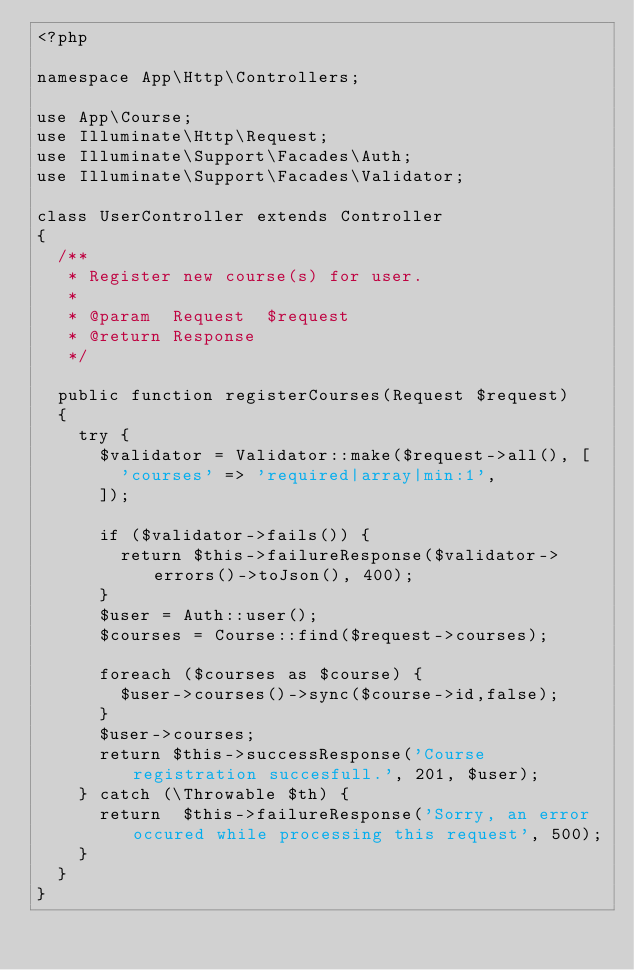Convert code to text. <code><loc_0><loc_0><loc_500><loc_500><_PHP_><?php

namespace App\Http\Controllers;

use App\Course;
use Illuminate\Http\Request;
use Illuminate\Support\Facades\Auth;
use Illuminate\Support\Facades\Validator;

class UserController extends Controller
{
  /**
   * Register new course(s) for user.
   *
   * @param  Request  $request
   * @return Response
   */

  public function registerCourses(Request $request)
  {
    try {
      $validator = Validator::make($request->all(), [
        'courses' => 'required|array|min:1',
      ]);

      if ($validator->fails()) {
        return $this->failureResponse($validator->errors()->toJson(), 400);
      }
      $user = Auth::user();
      $courses = Course::find($request->courses);

      foreach ($courses as $course) {
        $user->courses()->sync($course->id,false);
      }
      $user->courses;
      return $this->successResponse('Course registration succesfull.', 201, $user);
    } catch (\Throwable $th) {
      return  $this->failureResponse('Sorry, an error occured while processing this request', 500);
    }
  }
}
</code> 